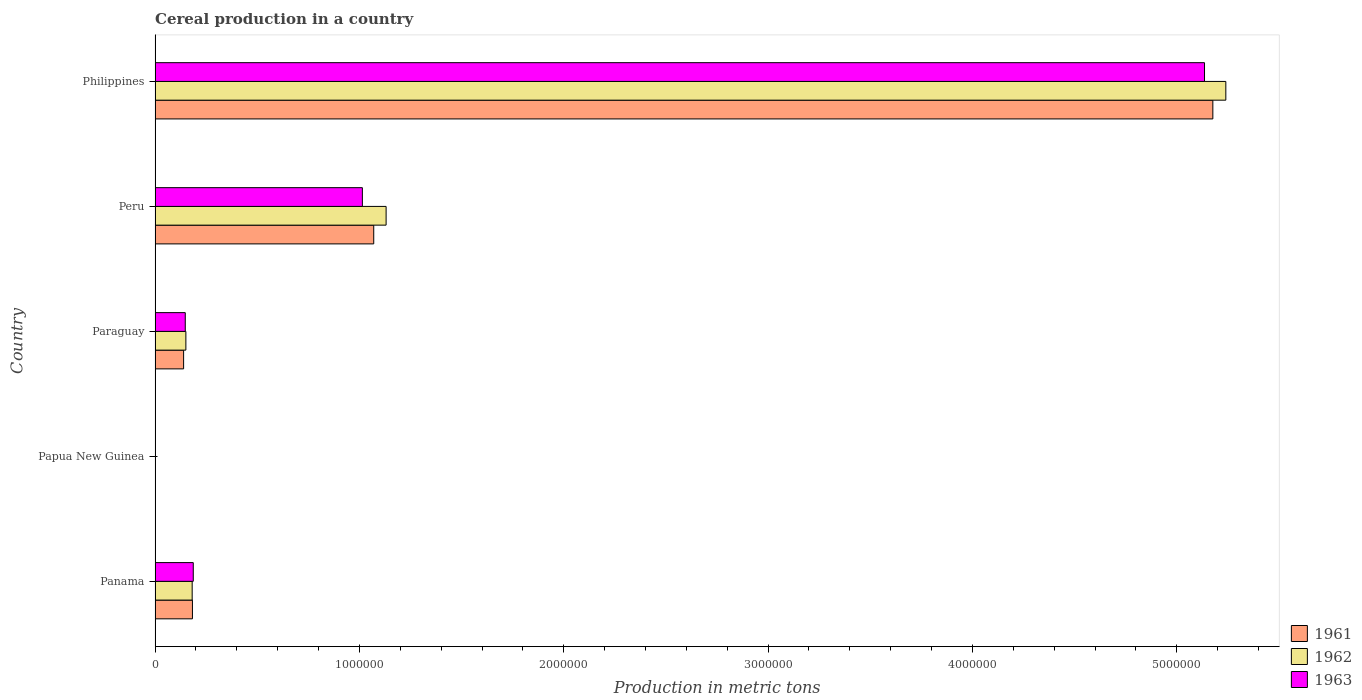How many groups of bars are there?
Your response must be concise. 5. What is the label of the 4th group of bars from the top?
Provide a succinct answer. Papua New Guinea. What is the total cereal production in 1961 in Panama?
Give a very brief answer. 1.83e+05. Across all countries, what is the maximum total cereal production in 1963?
Provide a short and direct response. 5.14e+06. Across all countries, what is the minimum total cereal production in 1962?
Provide a short and direct response. 1891. In which country was the total cereal production in 1963 maximum?
Give a very brief answer. Philippines. In which country was the total cereal production in 1963 minimum?
Ensure brevity in your answer.  Papua New Guinea. What is the total total cereal production in 1963 in the graph?
Provide a short and direct response. 6.49e+06. What is the difference between the total cereal production in 1961 in Papua New Guinea and that in Peru?
Provide a short and direct response. -1.07e+06. What is the difference between the total cereal production in 1963 in Philippines and the total cereal production in 1962 in Papua New Guinea?
Your answer should be very brief. 5.13e+06. What is the average total cereal production in 1963 per country?
Keep it short and to the point. 1.30e+06. What is the difference between the total cereal production in 1963 and total cereal production in 1962 in Panama?
Your answer should be very brief. 5407. What is the ratio of the total cereal production in 1962 in Panama to that in Papua New Guinea?
Your response must be concise. 96.03. Is the total cereal production in 1963 in Panama less than that in Philippines?
Give a very brief answer. Yes. Is the difference between the total cereal production in 1963 in Panama and Papua New Guinea greater than the difference between the total cereal production in 1962 in Panama and Papua New Guinea?
Give a very brief answer. Yes. What is the difference between the highest and the second highest total cereal production in 1962?
Your answer should be compact. 4.11e+06. What is the difference between the highest and the lowest total cereal production in 1963?
Your answer should be very brief. 5.13e+06. Is the sum of the total cereal production in 1961 in Peru and Philippines greater than the maximum total cereal production in 1963 across all countries?
Make the answer very short. Yes. What does the 2nd bar from the top in Paraguay represents?
Offer a terse response. 1962. How many bars are there?
Your answer should be very brief. 15. How many legend labels are there?
Your response must be concise. 3. What is the title of the graph?
Your answer should be compact. Cereal production in a country. Does "2004" appear as one of the legend labels in the graph?
Keep it short and to the point. No. What is the label or title of the X-axis?
Your response must be concise. Production in metric tons. What is the Production in metric tons in 1961 in Panama?
Give a very brief answer. 1.83e+05. What is the Production in metric tons in 1962 in Panama?
Provide a succinct answer. 1.82e+05. What is the Production in metric tons of 1963 in Panama?
Keep it short and to the point. 1.87e+05. What is the Production in metric tons in 1961 in Papua New Guinea?
Give a very brief answer. 1850. What is the Production in metric tons in 1962 in Papua New Guinea?
Make the answer very short. 1891. What is the Production in metric tons of 1963 in Papua New Guinea?
Ensure brevity in your answer.  1871. What is the Production in metric tons in 1961 in Paraguay?
Your answer should be compact. 1.40e+05. What is the Production in metric tons in 1962 in Paraguay?
Provide a succinct answer. 1.51e+05. What is the Production in metric tons of 1963 in Paraguay?
Ensure brevity in your answer.  1.48e+05. What is the Production in metric tons of 1961 in Peru?
Offer a very short reply. 1.07e+06. What is the Production in metric tons in 1962 in Peru?
Offer a terse response. 1.13e+06. What is the Production in metric tons of 1963 in Peru?
Provide a succinct answer. 1.01e+06. What is the Production in metric tons of 1961 in Philippines?
Make the answer very short. 5.18e+06. What is the Production in metric tons in 1962 in Philippines?
Offer a terse response. 5.24e+06. What is the Production in metric tons in 1963 in Philippines?
Provide a short and direct response. 5.14e+06. Across all countries, what is the maximum Production in metric tons of 1961?
Make the answer very short. 5.18e+06. Across all countries, what is the maximum Production in metric tons in 1962?
Ensure brevity in your answer.  5.24e+06. Across all countries, what is the maximum Production in metric tons in 1963?
Make the answer very short. 5.14e+06. Across all countries, what is the minimum Production in metric tons in 1961?
Give a very brief answer. 1850. Across all countries, what is the minimum Production in metric tons in 1962?
Your answer should be compact. 1891. Across all countries, what is the minimum Production in metric tons of 1963?
Your response must be concise. 1871. What is the total Production in metric tons of 1961 in the graph?
Keep it short and to the point. 6.57e+06. What is the total Production in metric tons of 1962 in the graph?
Your answer should be very brief. 6.70e+06. What is the total Production in metric tons of 1963 in the graph?
Ensure brevity in your answer.  6.49e+06. What is the difference between the Production in metric tons of 1961 in Panama and that in Papua New Guinea?
Offer a very short reply. 1.81e+05. What is the difference between the Production in metric tons of 1962 in Panama and that in Papua New Guinea?
Your answer should be compact. 1.80e+05. What is the difference between the Production in metric tons in 1963 in Panama and that in Papua New Guinea?
Offer a very short reply. 1.85e+05. What is the difference between the Production in metric tons in 1961 in Panama and that in Paraguay?
Ensure brevity in your answer.  4.32e+04. What is the difference between the Production in metric tons in 1962 in Panama and that in Paraguay?
Offer a very short reply. 3.08e+04. What is the difference between the Production in metric tons of 1963 in Panama and that in Paraguay?
Provide a short and direct response. 3.92e+04. What is the difference between the Production in metric tons in 1961 in Panama and that in Peru?
Offer a terse response. -8.87e+05. What is the difference between the Production in metric tons of 1962 in Panama and that in Peru?
Keep it short and to the point. -9.49e+05. What is the difference between the Production in metric tons in 1963 in Panama and that in Peru?
Offer a terse response. -8.27e+05. What is the difference between the Production in metric tons in 1961 in Panama and that in Philippines?
Make the answer very short. -4.99e+06. What is the difference between the Production in metric tons in 1962 in Panama and that in Philippines?
Give a very brief answer. -5.06e+06. What is the difference between the Production in metric tons of 1963 in Panama and that in Philippines?
Your answer should be compact. -4.95e+06. What is the difference between the Production in metric tons of 1961 in Papua New Guinea and that in Paraguay?
Your answer should be compact. -1.38e+05. What is the difference between the Production in metric tons of 1962 in Papua New Guinea and that in Paraguay?
Your response must be concise. -1.49e+05. What is the difference between the Production in metric tons in 1963 in Papua New Guinea and that in Paraguay?
Ensure brevity in your answer.  -1.46e+05. What is the difference between the Production in metric tons in 1961 in Papua New Guinea and that in Peru?
Keep it short and to the point. -1.07e+06. What is the difference between the Production in metric tons in 1962 in Papua New Guinea and that in Peru?
Provide a succinct answer. -1.13e+06. What is the difference between the Production in metric tons of 1963 in Papua New Guinea and that in Peru?
Make the answer very short. -1.01e+06. What is the difference between the Production in metric tons of 1961 in Papua New Guinea and that in Philippines?
Ensure brevity in your answer.  -5.17e+06. What is the difference between the Production in metric tons of 1962 in Papua New Guinea and that in Philippines?
Provide a short and direct response. -5.24e+06. What is the difference between the Production in metric tons in 1963 in Papua New Guinea and that in Philippines?
Provide a short and direct response. -5.13e+06. What is the difference between the Production in metric tons in 1961 in Paraguay and that in Peru?
Keep it short and to the point. -9.30e+05. What is the difference between the Production in metric tons in 1962 in Paraguay and that in Peru?
Provide a short and direct response. -9.80e+05. What is the difference between the Production in metric tons of 1963 in Paraguay and that in Peru?
Offer a terse response. -8.67e+05. What is the difference between the Production in metric tons of 1961 in Paraguay and that in Philippines?
Provide a succinct answer. -5.04e+06. What is the difference between the Production in metric tons of 1962 in Paraguay and that in Philippines?
Give a very brief answer. -5.09e+06. What is the difference between the Production in metric tons in 1963 in Paraguay and that in Philippines?
Provide a succinct answer. -4.99e+06. What is the difference between the Production in metric tons of 1961 in Peru and that in Philippines?
Your answer should be very brief. -4.11e+06. What is the difference between the Production in metric tons of 1962 in Peru and that in Philippines?
Your answer should be compact. -4.11e+06. What is the difference between the Production in metric tons of 1963 in Peru and that in Philippines?
Provide a succinct answer. -4.12e+06. What is the difference between the Production in metric tons in 1961 in Panama and the Production in metric tons in 1962 in Papua New Guinea?
Your answer should be very brief. 1.81e+05. What is the difference between the Production in metric tons in 1961 in Panama and the Production in metric tons in 1963 in Papua New Guinea?
Ensure brevity in your answer.  1.81e+05. What is the difference between the Production in metric tons of 1962 in Panama and the Production in metric tons of 1963 in Papua New Guinea?
Keep it short and to the point. 1.80e+05. What is the difference between the Production in metric tons of 1961 in Panama and the Production in metric tons of 1962 in Paraguay?
Keep it short and to the point. 3.21e+04. What is the difference between the Production in metric tons of 1961 in Panama and the Production in metric tons of 1963 in Paraguay?
Your answer should be very brief. 3.51e+04. What is the difference between the Production in metric tons of 1962 in Panama and the Production in metric tons of 1963 in Paraguay?
Provide a succinct answer. 3.38e+04. What is the difference between the Production in metric tons of 1961 in Panama and the Production in metric tons of 1962 in Peru?
Make the answer very short. -9.48e+05. What is the difference between the Production in metric tons in 1961 in Panama and the Production in metric tons in 1963 in Peru?
Your answer should be compact. -8.32e+05. What is the difference between the Production in metric tons of 1962 in Panama and the Production in metric tons of 1963 in Peru?
Your answer should be compact. -8.33e+05. What is the difference between the Production in metric tons of 1961 in Panama and the Production in metric tons of 1962 in Philippines?
Your answer should be compact. -5.06e+06. What is the difference between the Production in metric tons in 1961 in Panama and the Production in metric tons in 1963 in Philippines?
Offer a very short reply. -4.95e+06. What is the difference between the Production in metric tons of 1962 in Panama and the Production in metric tons of 1963 in Philippines?
Provide a short and direct response. -4.95e+06. What is the difference between the Production in metric tons of 1961 in Papua New Guinea and the Production in metric tons of 1962 in Paraguay?
Keep it short and to the point. -1.49e+05. What is the difference between the Production in metric tons of 1961 in Papua New Guinea and the Production in metric tons of 1963 in Paraguay?
Offer a very short reply. -1.46e+05. What is the difference between the Production in metric tons in 1962 in Papua New Guinea and the Production in metric tons in 1963 in Paraguay?
Your response must be concise. -1.46e+05. What is the difference between the Production in metric tons of 1961 in Papua New Guinea and the Production in metric tons of 1962 in Peru?
Give a very brief answer. -1.13e+06. What is the difference between the Production in metric tons of 1961 in Papua New Guinea and the Production in metric tons of 1963 in Peru?
Provide a short and direct response. -1.01e+06. What is the difference between the Production in metric tons of 1962 in Papua New Guinea and the Production in metric tons of 1963 in Peru?
Provide a succinct answer. -1.01e+06. What is the difference between the Production in metric tons of 1961 in Papua New Guinea and the Production in metric tons of 1962 in Philippines?
Provide a short and direct response. -5.24e+06. What is the difference between the Production in metric tons in 1961 in Papua New Guinea and the Production in metric tons in 1963 in Philippines?
Your answer should be compact. -5.13e+06. What is the difference between the Production in metric tons of 1962 in Papua New Guinea and the Production in metric tons of 1963 in Philippines?
Your answer should be compact. -5.13e+06. What is the difference between the Production in metric tons of 1961 in Paraguay and the Production in metric tons of 1962 in Peru?
Your answer should be compact. -9.91e+05. What is the difference between the Production in metric tons in 1961 in Paraguay and the Production in metric tons in 1963 in Peru?
Ensure brevity in your answer.  -8.75e+05. What is the difference between the Production in metric tons in 1962 in Paraguay and the Production in metric tons in 1963 in Peru?
Offer a very short reply. -8.64e+05. What is the difference between the Production in metric tons of 1961 in Paraguay and the Production in metric tons of 1962 in Philippines?
Offer a very short reply. -5.10e+06. What is the difference between the Production in metric tons in 1961 in Paraguay and the Production in metric tons in 1963 in Philippines?
Provide a succinct answer. -5.00e+06. What is the difference between the Production in metric tons of 1962 in Paraguay and the Production in metric tons of 1963 in Philippines?
Offer a terse response. -4.98e+06. What is the difference between the Production in metric tons in 1961 in Peru and the Production in metric tons in 1962 in Philippines?
Provide a succinct answer. -4.17e+06. What is the difference between the Production in metric tons in 1961 in Peru and the Production in metric tons in 1963 in Philippines?
Give a very brief answer. -4.07e+06. What is the difference between the Production in metric tons of 1962 in Peru and the Production in metric tons of 1963 in Philippines?
Provide a short and direct response. -4.00e+06. What is the average Production in metric tons in 1961 per country?
Give a very brief answer. 1.31e+06. What is the average Production in metric tons of 1962 per country?
Give a very brief answer. 1.34e+06. What is the average Production in metric tons of 1963 per country?
Offer a terse response. 1.30e+06. What is the difference between the Production in metric tons of 1961 and Production in metric tons of 1962 in Panama?
Keep it short and to the point. 1297. What is the difference between the Production in metric tons of 1961 and Production in metric tons of 1963 in Panama?
Give a very brief answer. -4110. What is the difference between the Production in metric tons in 1962 and Production in metric tons in 1963 in Panama?
Ensure brevity in your answer.  -5407. What is the difference between the Production in metric tons in 1961 and Production in metric tons in 1962 in Papua New Guinea?
Offer a very short reply. -41. What is the difference between the Production in metric tons in 1961 and Production in metric tons in 1963 in Papua New Guinea?
Your answer should be compact. -21. What is the difference between the Production in metric tons of 1962 and Production in metric tons of 1963 in Papua New Guinea?
Provide a succinct answer. 20. What is the difference between the Production in metric tons in 1961 and Production in metric tons in 1962 in Paraguay?
Give a very brief answer. -1.11e+04. What is the difference between the Production in metric tons in 1961 and Production in metric tons in 1963 in Paraguay?
Keep it short and to the point. -8100. What is the difference between the Production in metric tons in 1962 and Production in metric tons in 1963 in Paraguay?
Offer a terse response. 3000. What is the difference between the Production in metric tons in 1961 and Production in metric tons in 1962 in Peru?
Your answer should be very brief. -6.05e+04. What is the difference between the Production in metric tons of 1961 and Production in metric tons of 1963 in Peru?
Your answer should be very brief. 5.57e+04. What is the difference between the Production in metric tons of 1962 and Production in metric tons of 1963 in Peru?
Provide a succinct answer. 1.16e+05. What is the difference between the Production in metric tons in 1961 and Production in metric tons in 1962 in Philippines?
Keep it short and to the point. -6.35e+04. What is the difference between the Production in metric tons of 1961 and Production in metric tons of 1963 in Philippines?
Provide a succinct answer. 4.08e+04. What is the difference between the Production in metric tons in 1962 and Production in metric tons in 1963 in Philippines?
Give a very brief answer. 1.04e+05. What is the ratio of the Production in metric tons of 1961 in Panama to that in Papua New Guinea?
Offer a terse response. 98.86. What is the ratio of the Production in metric tons of 1962 in Panama to that in Papua New Guinea?
Offer a very short reply. 96.03. What is the ratio of the Production in metric tons in 1963 in Panama to that in Papua New Guinea?
Provide a succinct answer. 99.94. What is the ratio of the Production in metric tons of 1961 in Panama to that in Paraguay?
Your answer should be very brief. 1.31. What is the ratio of the Production in metric tons in 1962 in Panama to that in Paraguay?
Make the answer very short. 1.2. What is the ratio of the Production in metric tons of 1963 in Panama to that in Paraguay?
Give a very brief answer. 1.27. What is the ratio of the Production in metric tons in 1961 in Panama to that in Peru?
Make the answer very short. 0.17. What is the ratio of the Production in metric tons in 1962 in Panama to that in Peru?
Keep it short and to the point. 0.16. What is the ratio of the Production in metric tons of 1963 in Panama to that in Peru?
Your response must be concise. 0.18. What is the ratio of the Production in metric tons of 1961 in Panama to that in Philippines?
Your answer should be very brief. 0.04. What is the ratio of the Production in metric tons in 1962 in Panama to that in Philippines?
Ensure brevity in your answer.  0.03. What is the ratio of the Production in metric tons of 1963 in Panama to that in Philippines?
Provide a short and direct response. 0.04. What is the ratio of the Production in metric tons of 1961 in Papua New Guinea to that in Paraguay?
Provide a short and direct response. 0.01. What is the ratio of the Production in metric tons in 1962 in Papua New Guinea to that in Paraguay?
Provide a short and direct response. 0.01. What is the ratio of the Production in metric tons of 1963 in Papua New Guinea to that in Paraguay?
Your answer should be very brief. 0.01. What is the ratio of the Production in metric tons of 1961 in Papua New Guinea to that in Peru?
Offer a very short reply. 0. What is the ratio of the Production in metric tons in 1962 in Papua New Guinea to that in Peru?
Your response must be concise. 0. What is the ratio of the Production in metric tons of 1963 in Papua New Guinea to that in Peru?
Ensure brevity in your answer.  0. What is the ratio of the Production in metric tons of 1961 in Paraguay to that in Peru?
Keep it short and to the point. 0.13. What is the ratio of the Production in metric tons of 1962 in Paraguay to that in Peru?
Make the answer very short. 0.13. What is the ratio of the Production in metric tons of 1963 in Paraguay to that in Peru?
Offer a terse response. 0.15. What is the ratio of the Production in metric tons of 1961 in Paraguay to that in Philippines?
Keep it short and to the point. 0.03. What is the ratio of the Production in metric tons of 1962 in Paraguay to that in Philippines?
Keep it short and to the point. 0.03. What is the ratio of the Production in metric tons in 1963 in Paraguay to that in Philippines?
Make the answer very short. 0.03. What is the ratio of the Production in metric tons in 1961 in Peru to that in Philippines?
Ensure brevity in your answer.  0.21. What is the ratio of the Production in metric tons in 1962 in Peru to that in Philippines?
Your answer should be very brief. 0.22. What is the ratio of the Production in metric tons of 1963 in Peru to that in Philippines?
Keep it short and to the point. 0.2. What is the difference between the highest and the second highest Production in metric tons in 1961?
Your response must be concise. 4.11e+06. What is the difference between the highest and the second highest Production in metric tons of 1962?
Your response must be concise. 4.11e+06. What is the difference between the highest and the second highest Production in metric tons in 1963?
Your answer should be very brief. 4.12e+06. What is the difference between the highest and the lowest Production in metric tons of 1961?
Offer a terse response. 5.17e+06. What is the difference between the highest and the lowest Production in metric tons of 1962?
Make the answer very short. 5.24e+06. What is the difference between the highest and the lowest Production in metric tons in 1963?
Your answer should be compact. 5.13e+06. 